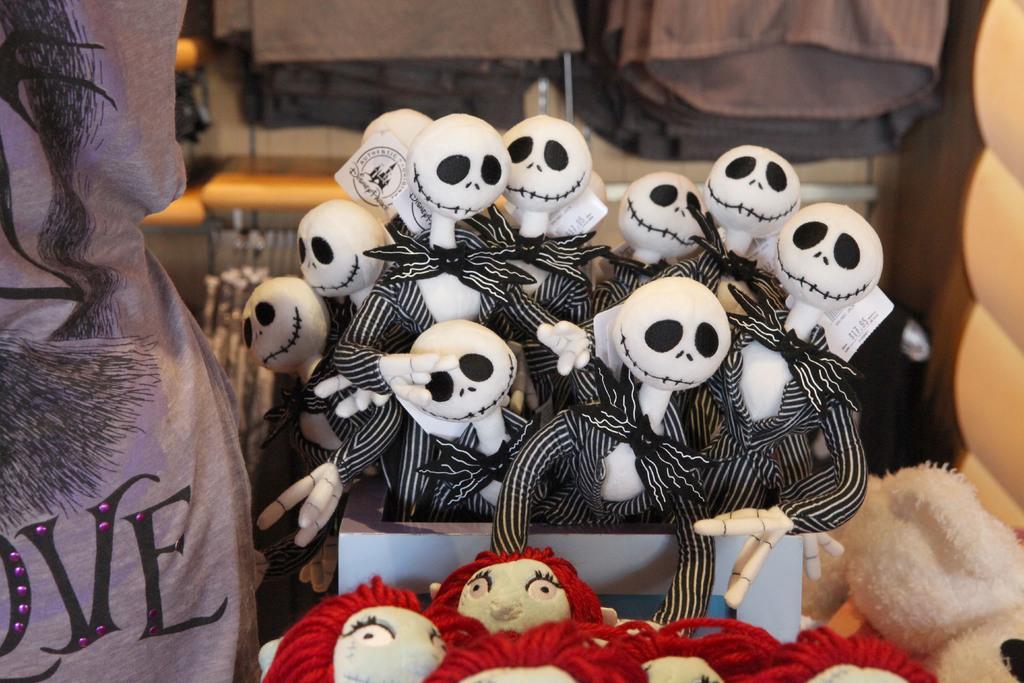Could you give a brief overview of what you see in this image? In this picture we can see few toys in the box and we can find blurry background. 